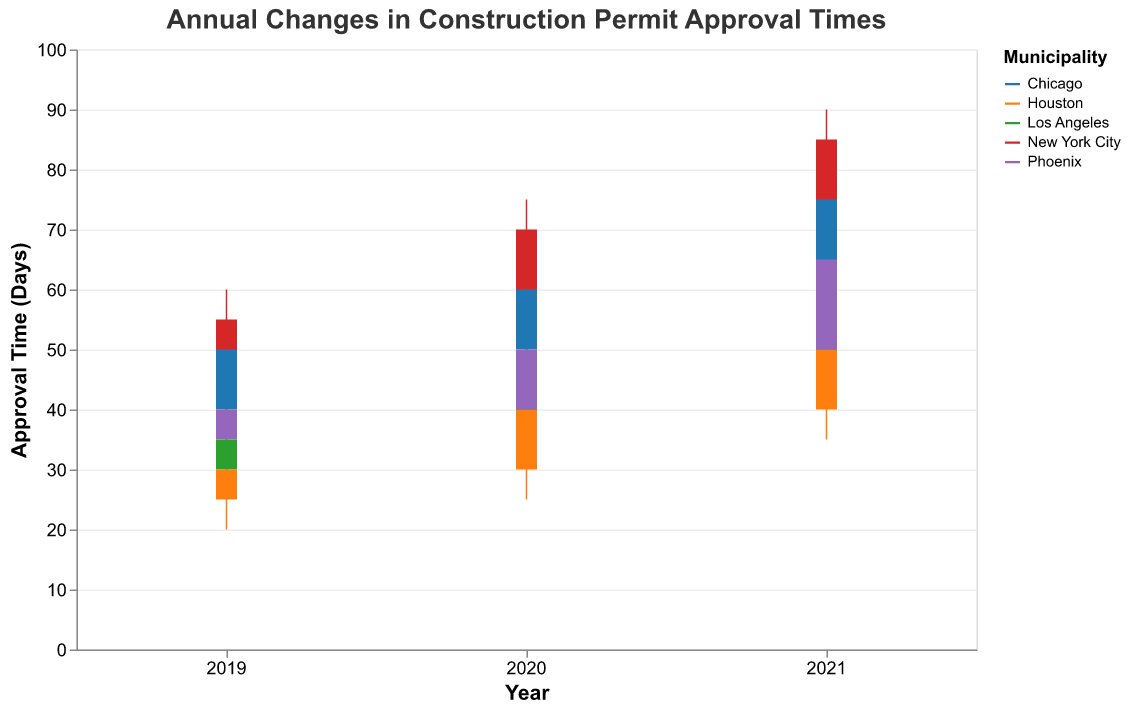What is the title of the chart? The title of the chart is at the top and reads "Annual Changes in Construction Permit Approval Times".
Answer: Annual Changes in Construction Permit Approval Times What do the colors in the chart represent? The colors represent different municipalities.
Answer: Different municipalities What is the y-axis title? The y-axis title, indicated on the left side, is "Approval Time (Days)".
Answer: Approval Time (Days) How many years of data are presented in the chart? The x-axis shows the years, and there are three years presented: 2019, 2020, and 2021.
Answer: Three years Which municipality had the highest approval time in 2021? Look at the point labeled 2021 for each municipality; New York City had the highest approval time with a high of 90 days.
Answer: New York City How did the approval time in Houston change from 2019 to 2020? In 2019, the approval time closed at 30 days, and in 2020, it closed at 40 days, indicating an increase of 10 days.
Answer: Increased by 10 days What was the lowest approval time recorded in Phoenix over the three years? Look at the lows for Phoenix across 2019, 2020, and 2021: 30, 35, and 45 days, respectively. The lowest was 30 days in 2019.
Answer: 30 days What is the average closing approval time for Los Angeles from 2019 to 2021? The closing times for Los Angeles are 35, 45, and 55 from 2019 to 2021. Sum them up (35 + 45 + 55) = 135. Divide by 3 to get the average: 135 / 3 = 45 days.
Answer: 45 days Which municipality had the largest range of approval times in 2021? Calculate the range for each municipality in 2021 by subtracting the low from the high. New York City has the largest range (90 - 65 = 25 days).
Answer: New York City Did any municipality have a decrease in closing approval time from 2020 to 2021? Compare the closing times from 2020 to 2021 for each municipality. No municipality had a decrease; all had either an increase or maintained the same.
Answer: No 